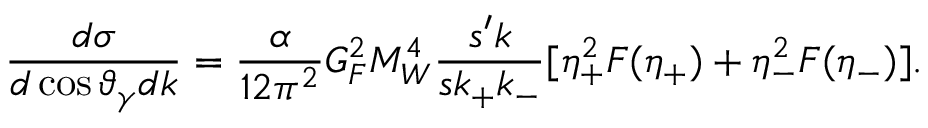Convert formula to latex. <formula><loc_0><loc_0><loc_500><loc_500>{ \frac { d \sigma } { d \cos \vartheta _ { \gamma } d k } } = { \frac { \alpha } { 1 2 \pi ^ { 2 } } } G _ { F } ^ { 2 } M _ { W } ^ { 4 } { \frac { s ^ { \prime } k } { s k _ { + } k _ { - } } } [ \eta _ { + } ^ { 2 } F ( \eta _ { + } ) + \eta _ { - } ^ { 2 } F ( \eta _ { - } ) ] .</formula> 